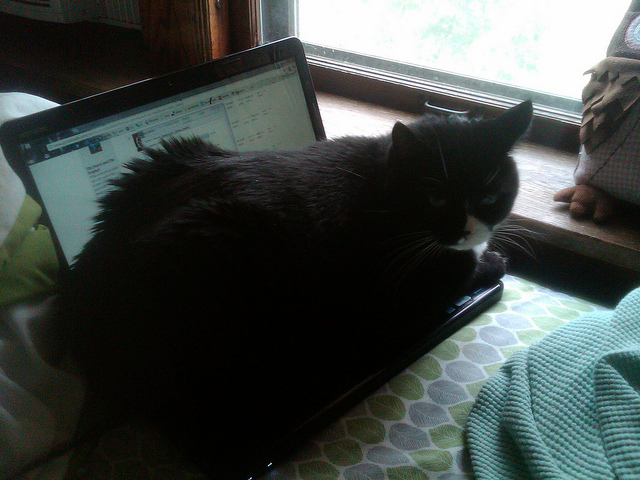Describe the environment this cat might be in, based on its comfortable position on the laptop. The environment seems to be a cozy indoor setting, possibly a home office. The cat appears quite at ease, lying on the laptop, which might indicate it feels secure and content in its surroundings, typical of indoor pets. 